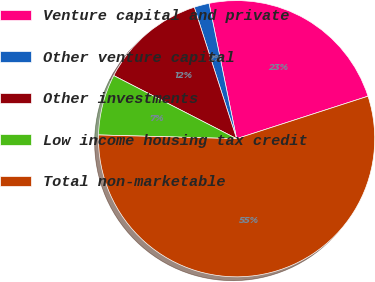Convert chart to OTSL. <chart><loc_0><loc_0><loc_500><loc_500><pie_chart><fcel>Venture capital and private<fcel>Other venture capital<fcel>Other investments<fcel>Low income housing tax credit<fcel>Total non-marketable<nl><fcel>23.22%<fcel>1.76%<fcel>12.49%<fcel>7.12%<fcel>55.41%<nl></chart> 